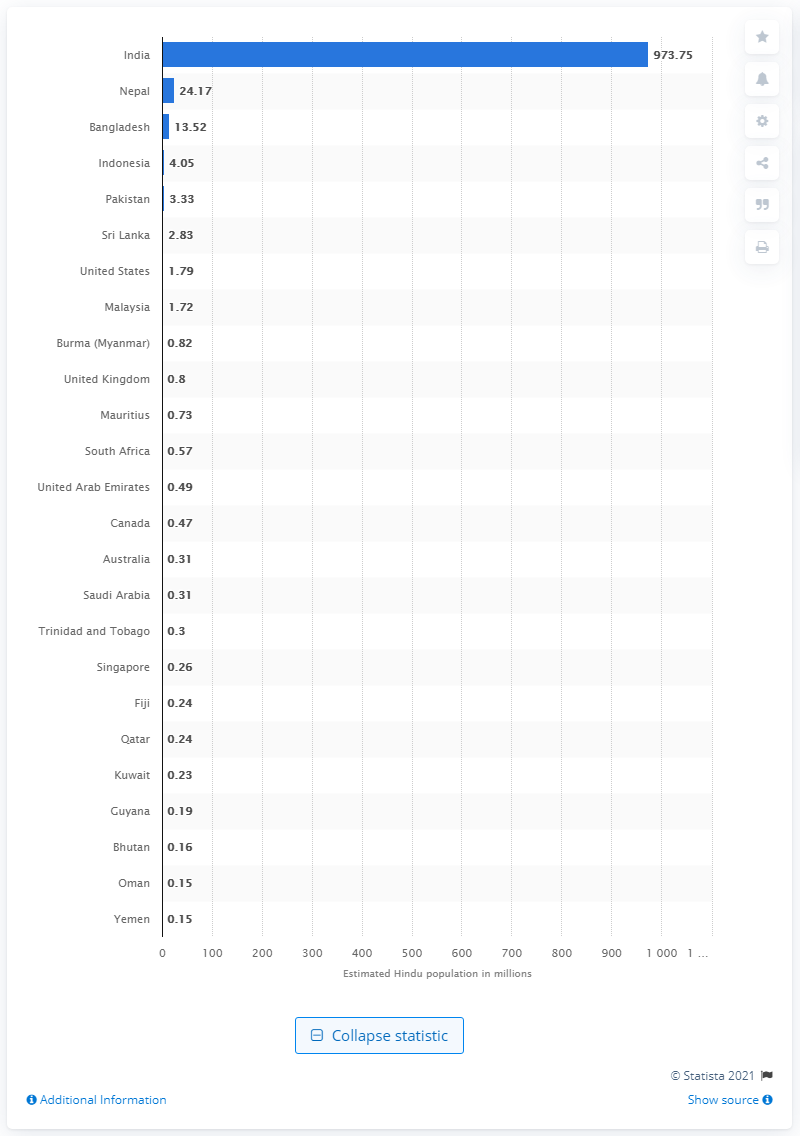Outline some significant characteristics in this image. In 2010, it is estimated that there were approximately 973.75 Hindus living in India. 